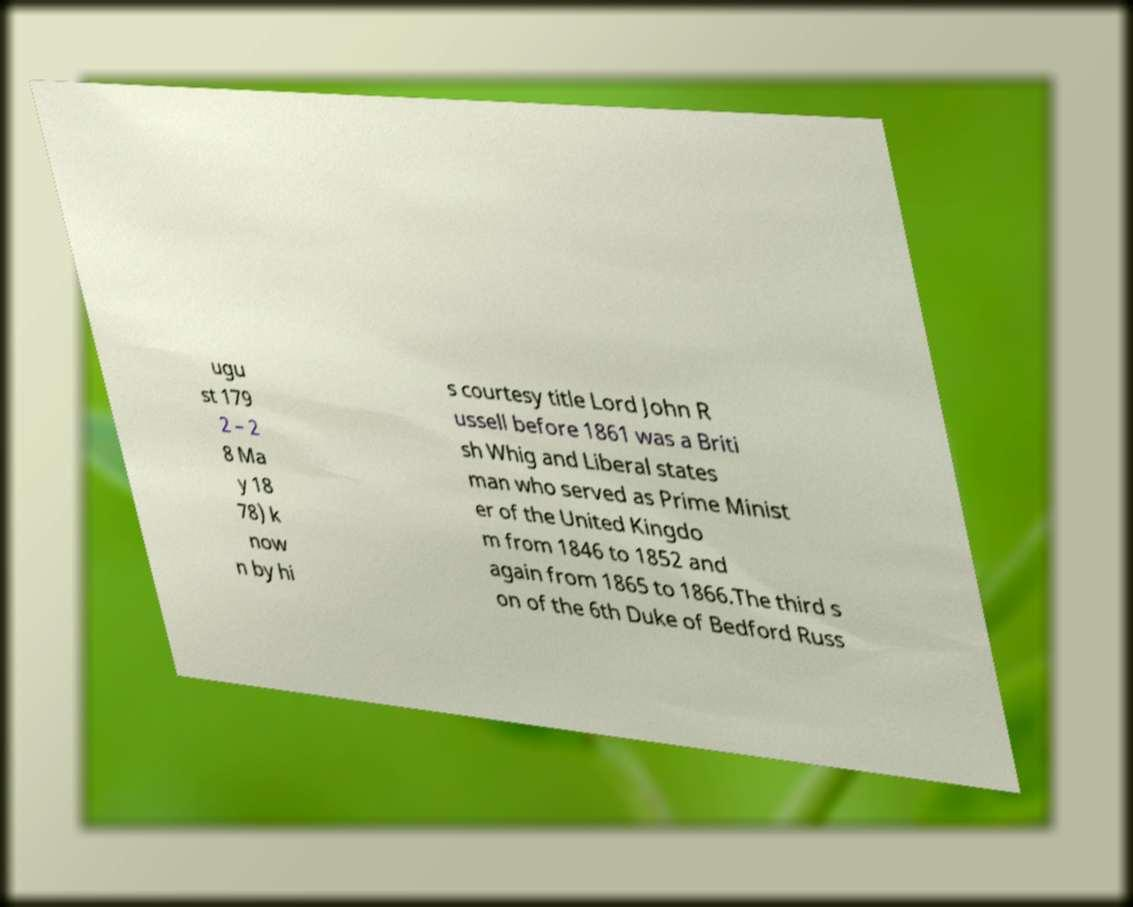Could you extract and type out the text from this image? ugu st 179 2 – 2 8 Ma y 18 78) k now n by hi s courtesy title Lord John R ussell before 1861 was a Briti sh Whig and Liberal states man who served as Prime Minist er of the United Kingdo m from 1846 to 1852 and again from 1865 to 1866.The third s on of the 6th Duke of Bedford Russ 